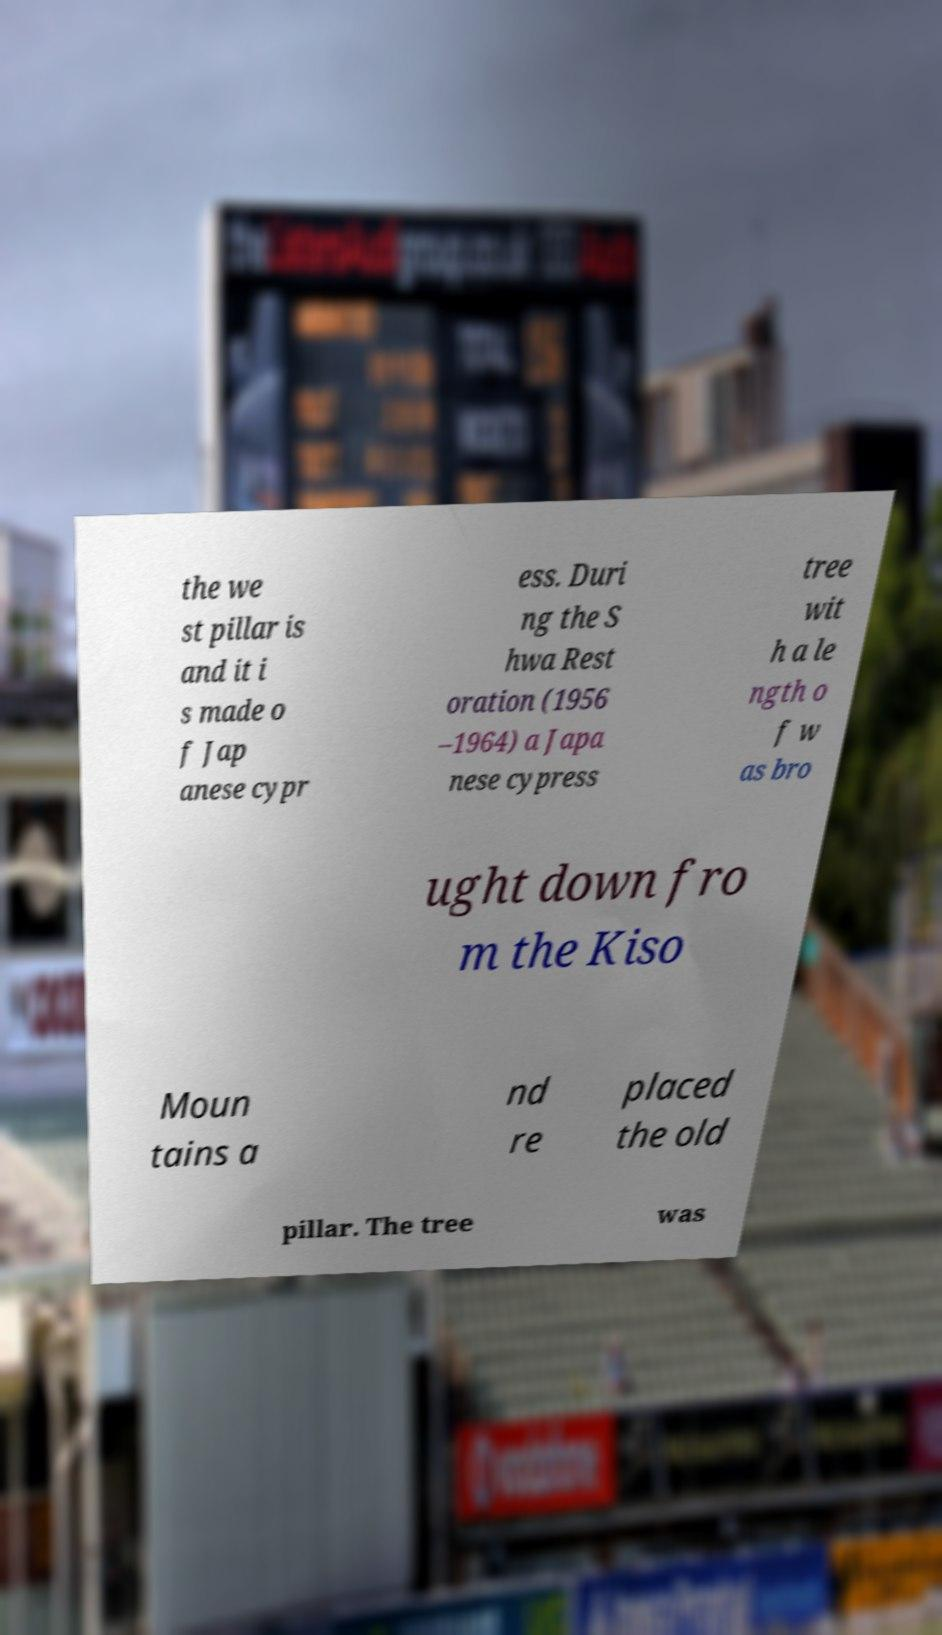Could you extract and type out the text from this image? the we st pillar is and it i s made o f Jap anese cypr ess. Duri ng the S hwa Rest oration (1956 –1964) a Japa nese cypress tree wit h a le ngth o f w as bro ught down fro m the Kiso Moun tains a nd re placed the old pillar. The tree was 